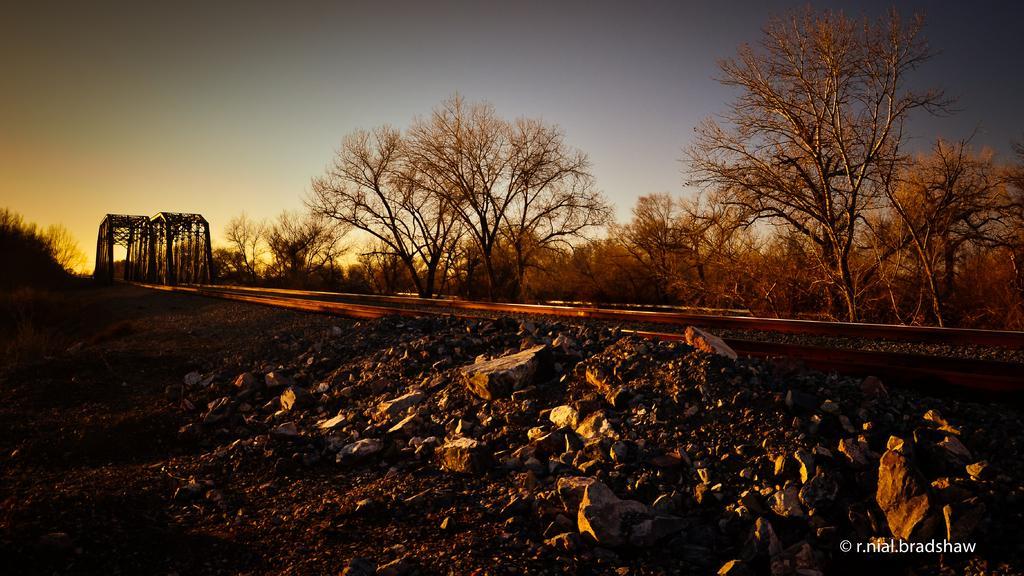How would you summarize this image in a sentence or two? In this image we can see some rocks, railway track, wooden poles, trees, also we can see the sky. 